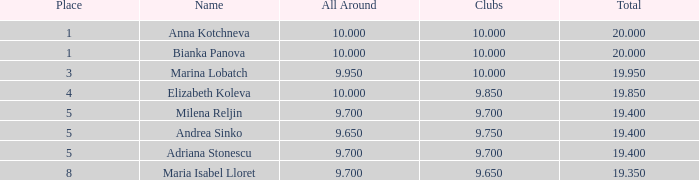In which combined amount are there 10 clubs, and the rank is above 1? 19.95. 